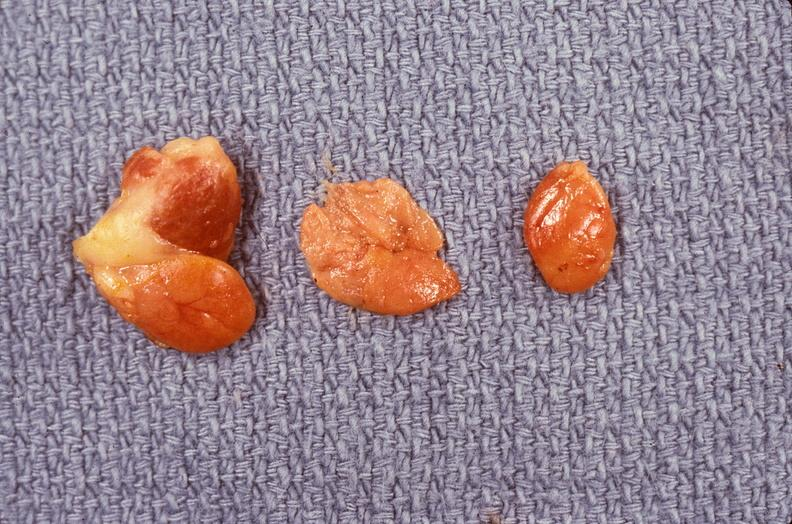s endocrine present?
Answer the question using a single word or phrase. Yes 